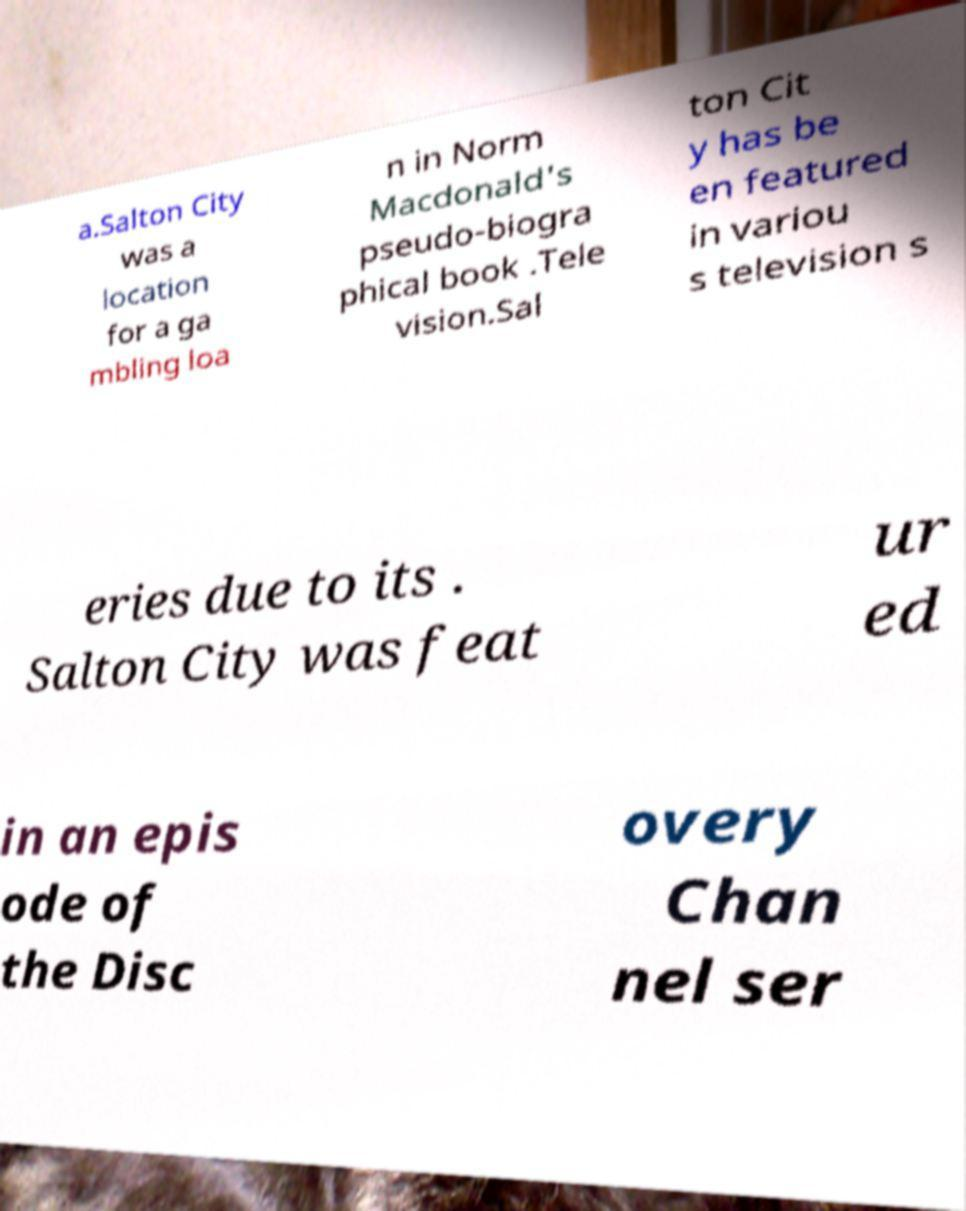Please read and relay the text visible in this image. What does it say? a.Salton City was a location for a ga mbling loa n in Norm Macdonald's pseudo-biogra phical book .Tele vision.Sal ton Cit y has be en featured in variou s television s eries due to its . Salton City was feat ur ed in an epis ode of the Disc overy Chan nel ser 